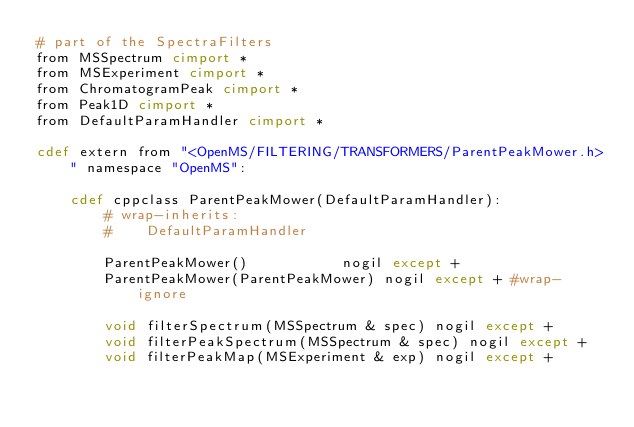Convert code to text. <code><loc_0><loc_0><loc_500><loc_500><_Cython_># part of the SpectraFilters
from MSSpectrum cimport *
from MSExperiment cimport *
from ChromatogramPeak cimport *
from Peak1D cimport *
from DefaultParamHandler cimport *

cdef extern from "<OpenMS/FILTERING/TRANSFORMERS/ParentPeakMower.h>" namespace "OpenMS":

    cdef cppclass ParentPeakMower(DefaultParamHandler):
        # wrap-inherits:
        #    DefaultParamHandler

        ParentPeakMower()           nogil except +
        ParentPeakMower(ParentPeakMower) nogil except + #wrap-ignore

        void filterSpectrum(MSSpectrum & spec) nogil except +
        void filterPeakSpectrum(MSSpectrum & spec) nogil except +
        void filterPeakMap(MSExperiment & exp) nogil except +

</code> 